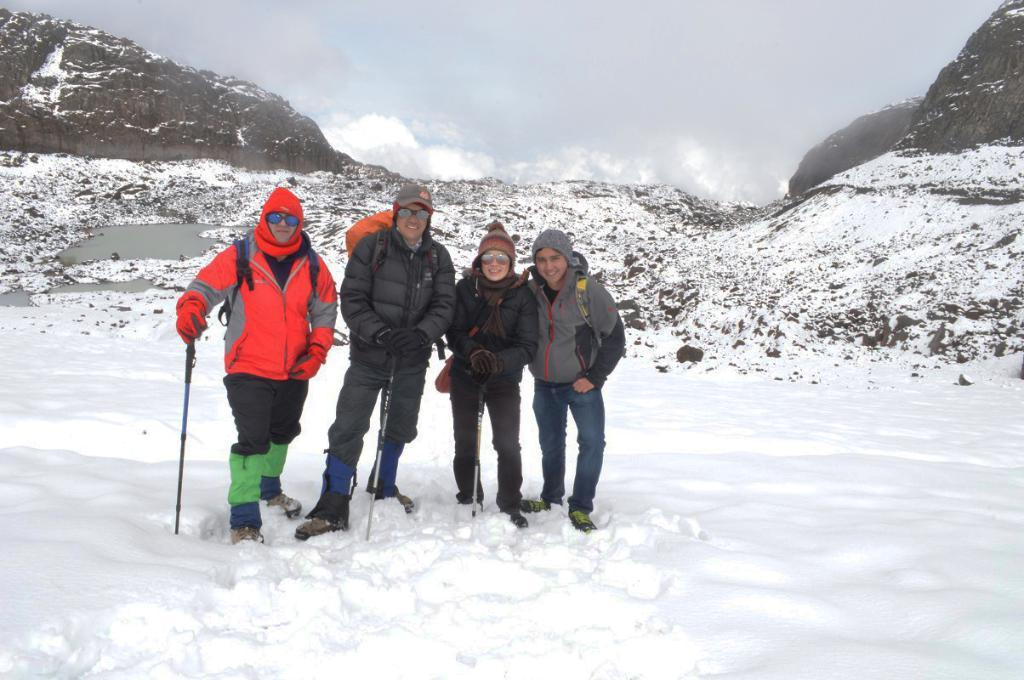How many people are in the image? There are four persons in the image. What are the persons standing on? The persons are standing on the snow. What are the persons holding in their hands? The persons are holding ski poles. What can be seen in the background of the image? There are snow mountains and the sky visible in the background of the image. What type of wood is being used to build the doghouse in the image? There is no doghouse or wood present in the image; it features four persons standing on snow and holding ski poles. What color is the flag that is being waved by the person in the image? There is no flag present in the image. 